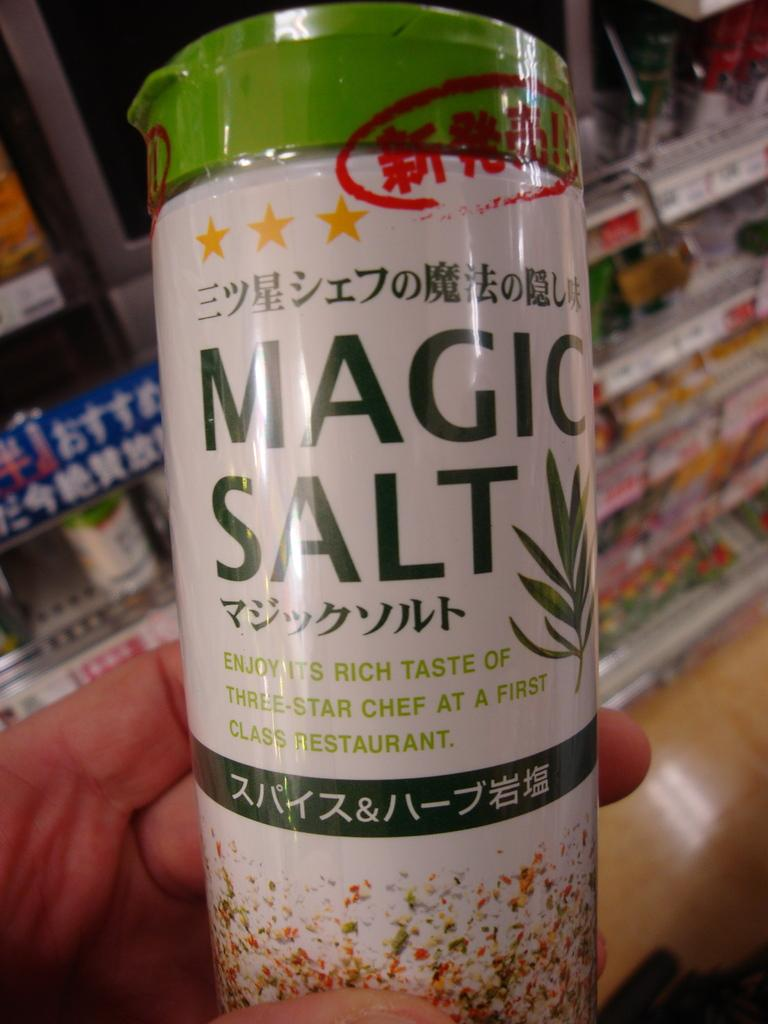<image>
Summarize the visual content of the image. A UNSEALED BOTTLE OF MAGIC SALT WITH ORINTAL WRITTING 